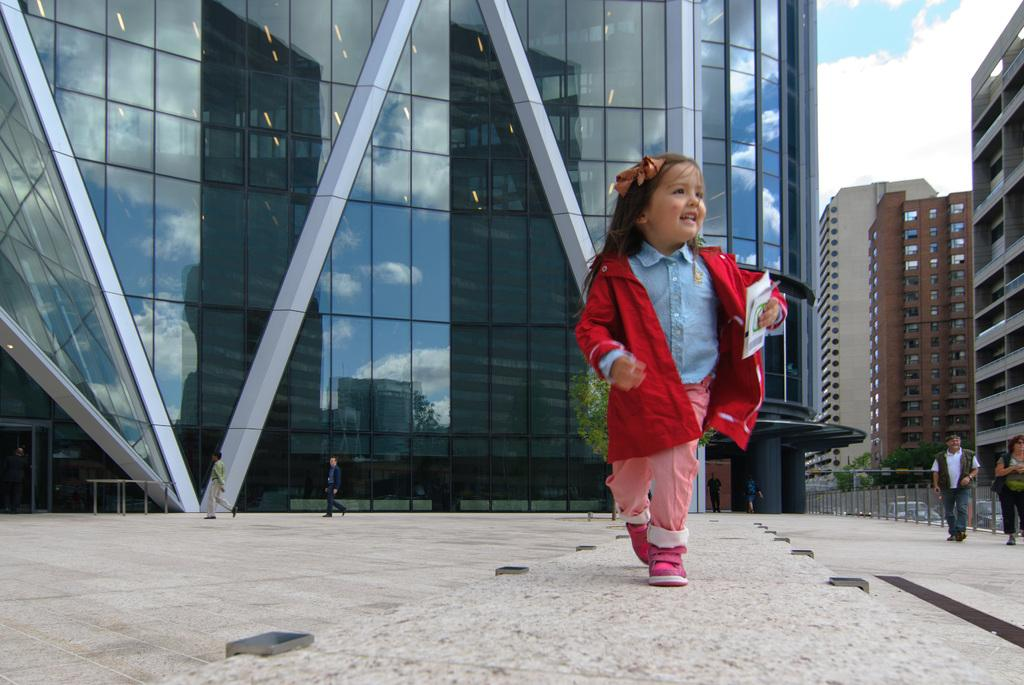Who or what can be seen in the image? There are people in the image. What structures are present in the image? There are buildings in the image. What mode of transportation can be seen in the image? There are vehicles in the image. What type of natural element is visible in the image? There are trees in the image. What part of the environment is visible in the image? The ground is visible in the image. What part of the natural environment is visible in the image? The sky is visible in the image, and there are clouds in the sky. What type of barrier is present in the image? There is a fence in the image. What type of rice is being cooked in the image? There is no rice present in the image. How many legs does the color have in the image? The question is unclear and seems to reference an absurd topic, as there is no mention of a color or legs in the provided facts. 